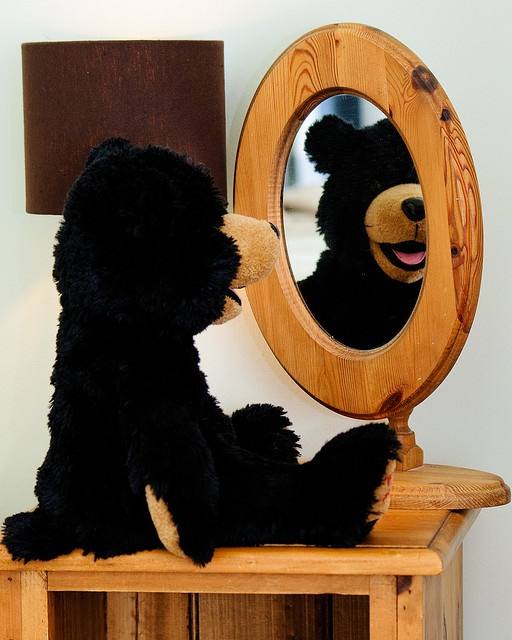Describe the objects in this image and their specific colors. I can see bear in white, black, tan, brown, and maroon tones, teddy bear in white, black, tan, red, and maroon tones, and teddy bear in white, black, brown, maroon, and lightgray tones in this image. 